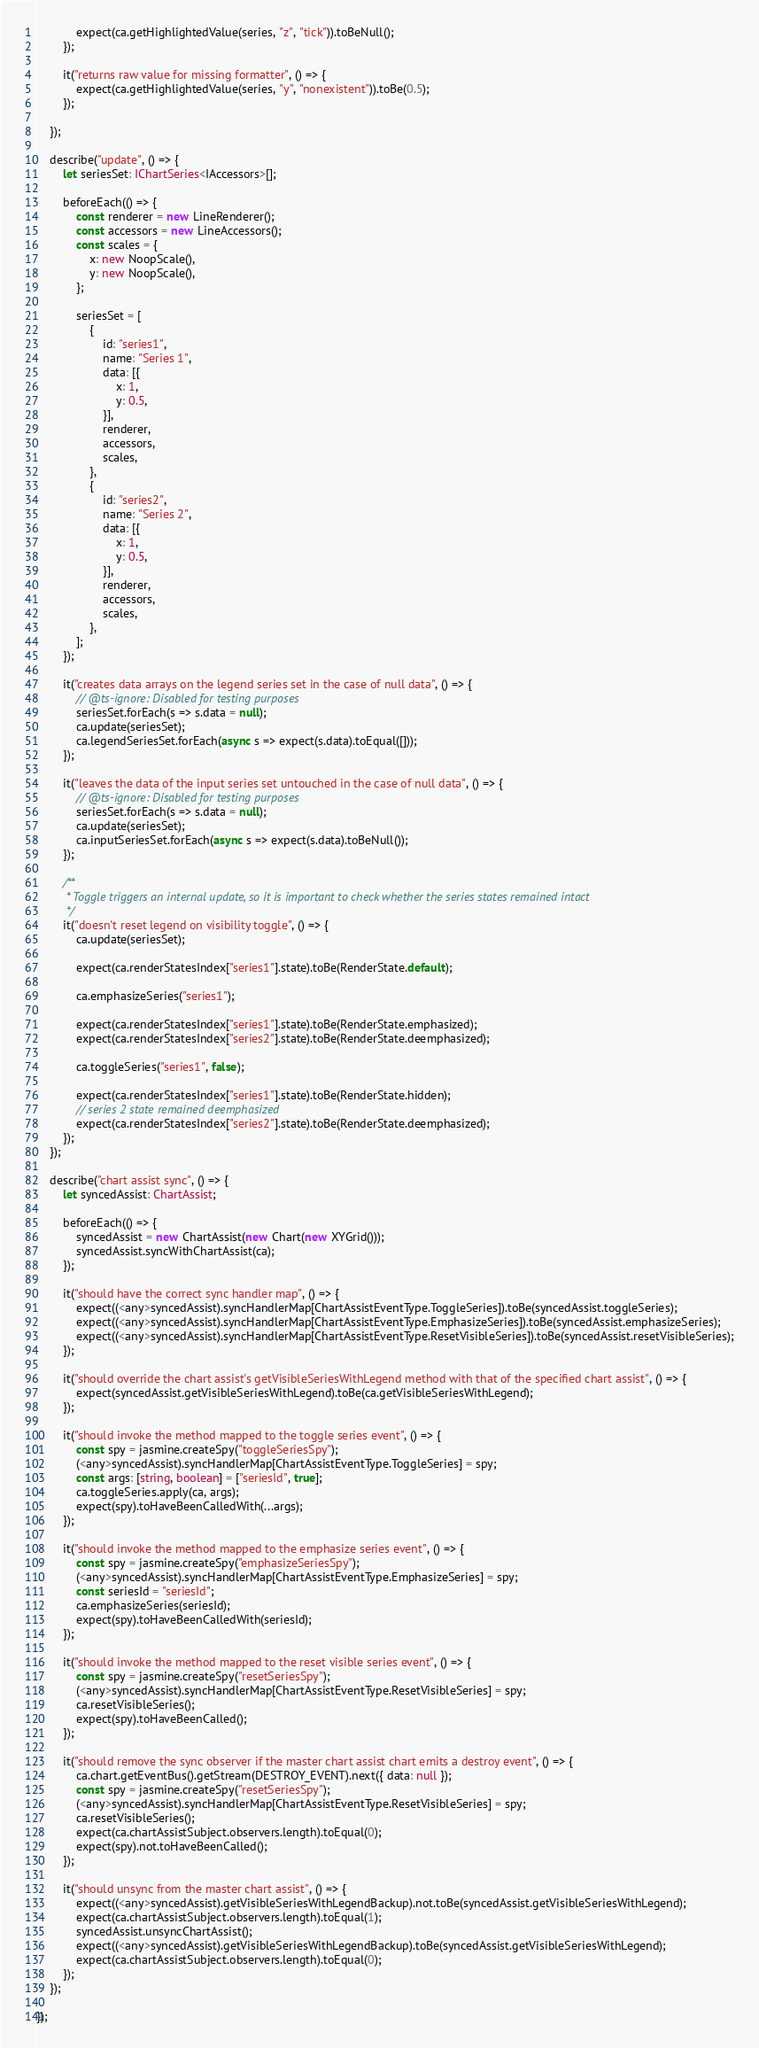Convert code to text. <code><loc_0><loc_0><loc_500><loc_500><_TypeScript_>            expect(ca.getHighlightedValue(series, "z", "tick")).toBeNull();
        });

        it("returns raw value for missing formatter", () => {
            expect(ca.getHighlightedValue(series, "y", "nonexistent")).toBe(0.5);
        });

    });

    describe("update", () => {
        let seriesSet: IChartSeries<IAccessors>[];

        beforeEach(() => {
            const renderer = new LineRenderer();
            const accessors = new LineAccessors();
            const scales = {
                x: new NoopScale(),
                y: new NoopScale(),
            };

            seriesSet = [
                {
                    id: "series1",
                    name: "Series 1",
                    data: [{
                        x: 1,
                        y: 0.5,
                    }],
                    renderer,
                    accessors,
                    scales,
                },
                {
                    id: "series2",
                    name: "Series 2",
                    data: [{
                        x: 1,
                        y: 0.5,
                    }],
                    renderer,
                    accessors,
                    scales,
                },
            ];
        });

        it("creates data arrays on the legend series set in the case of null data", () => {
            // @ts-ignore: Disabled for testing purposes
            seriesSet.forEach(s => s.data = null);
            ca.update(seriesSet);
            ca.legendSeriesSet.forEach(async s => expect(s.data).toEqual([]));
        });

        it("leaves the data of the input series set untouched in the case of null data", () => {
            // @ts-ignore: Disabled for testing purposes
            seriesSet.forEach(s => s.data = null);
            ca.update(seriesSet);
            ca.inputSeriesSet.forEach(async s => expect(s.data).toBeNull());
        });

        /**
         * Toggle triggers an internal update, so it is important to check whether the series states remained intact
         */
        it("doesn't reset legend on visibility toggle", () => {
            ca.update(seriesSet);

            expect(ca.renderStatesIndex["series1"].state).toBe(RenderState.default);

            ca.emphasizeSeries("series1");

            expect(ca.renderStatesIndex["series1"].state).toBe(RenderState.emphasized);
            expect(ca.renderStatesIndex["series2"].state).toBe(RenderState.deemphasized);

            ca.toggleSeries("series1", false);

            expect(ca.renderStatesIndex["series1"].state).toBe(RenderState.hidden);
            // series 2 state remained deemphasized
            expect(ca.renderStatesIndex["series2"].state).toBe(RenderState.deemphasized);
        });
    });

    describe("chart assist sync", () => {
        let syncedAssist: ChartAssist;

        beforeEach(() => {
            syncedAssist = new ChartAssist(new Chart(new XYGrid()));
            syncedAssist.syncWithChartAssist(ca);
        });

        it("should have the correct sync handler map", () => {
            expect((<any>syncedAssist).syncHandlerMap[ChartAssistEventType.ToggleSeries]).toBe(syncedAssist.toggleSeries);
            expect((<any>syncedAssist).syncHandlerMap[ChartAssistEventType.EmphasizeSeries]).toBe(syncedAssist.emphasizeSeries);
            expect((<any>syncedAssist).syncHandlerMap[ChartAssistEventType.ResetVisibleSeries]).toBe(syncedAssist.resetVisibleSeries);
        });

        it("should override the chart assist's getVisibleSeriesWithLegend method with that of the specified chart assist", () => {
            expect(syncedAssist.getVisibleSeriesWithLegend).toBe(ca.getVisibleSeriesWithLegend);
        });

        it("should invoke the method mapped to the toggle series event", () => {
            const spy = jasmine.createSpy("toggleSeriesSpy");
            (<any>syncedAssist).syncHandlerMap[ChartAssistEventType.ToggleSeries] = spy;
            const args: [string, boolean] = ["seriesId", true];
            ca.toggleSeries.apply(ca, args);
            expect(spy).toHaveBeenCalledWith(...args);
        });

        it("should invoke the method mapped to the emphasize series event", () => {
            const spy = jasmine.createSpy("emphasizeSeriesSpy");
            (<any>syncedAssist).syncHandlerMap[ChartAssistEventType.EmphasizeSeries] = spy;
            const seriesId = "seriesId";
            ca.emphasizeSeries(seriesId);
            expect(spy).toHaveBeenCalledWith(seriesId);
        });

        it("should invoke the method mapped to the reset visible series event", () => {
            const spy = jasmine.createSpy("resetSeriesSpy");
            (<any>syncedAssist).syncHandlerMap[ChartAssistEventType.ResetVisibleSeries] = spy;
            ca.resetVisibleSeries();
            expect(spy).toHaveBeenCalled();
        });

        it("should remove the sync observer if the master chart assist chart emits a destroy event", () => {
            ca.chart.getEventBus().getStream(DESTROY_EVENT).next({ data: null });
            const spy = jasmine.createSpy("resetSeriesSpy");
            (<any>syncedAssist).syncHandlerMap[ChartAssistEventType.ResetVisibleSeries] = spy;
            ca.resetVisibleSeries();
            expect(ca.chartAssistSubject.observers.length).toEqual(0);
            expect(spy).not.toHaveBeenCalled();
        });

        it("should unsync from the master chart assist", () => {
            expect((<any>syncedAssist).getVisibleSeriesWithLegendBackup).not.toBe(syncedAssist.getVisibleSeriesWithLegend);
            expect(ca.chartAssistSubject.observers.length).toEqual(1);
            syncedAssist.unsyncChartAssist();
            expect((<any>syncedAssist).getVisibleSeriesWithLegendBackup).toBe(syncedAssist.getVisibleSeriesWithLegend);
            expect(ca.chartAssistSubject.observers.length).toEqual(0);
        });
    });

});
</code> 